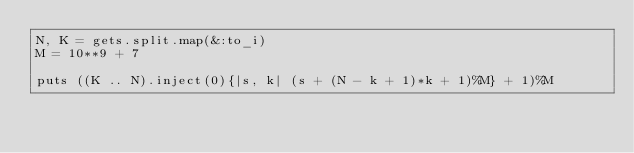Convert code to text. <code><loc_0><loc_0><loc_500><loc_500><_Ruby_>N, K = gets.split.map(&:to_i)
M = 10**9 + 7

puts ((K .. N).inject(0){|s, k| (s + (N - k + 1)*k + 1)%M} + 1)%M</code> 